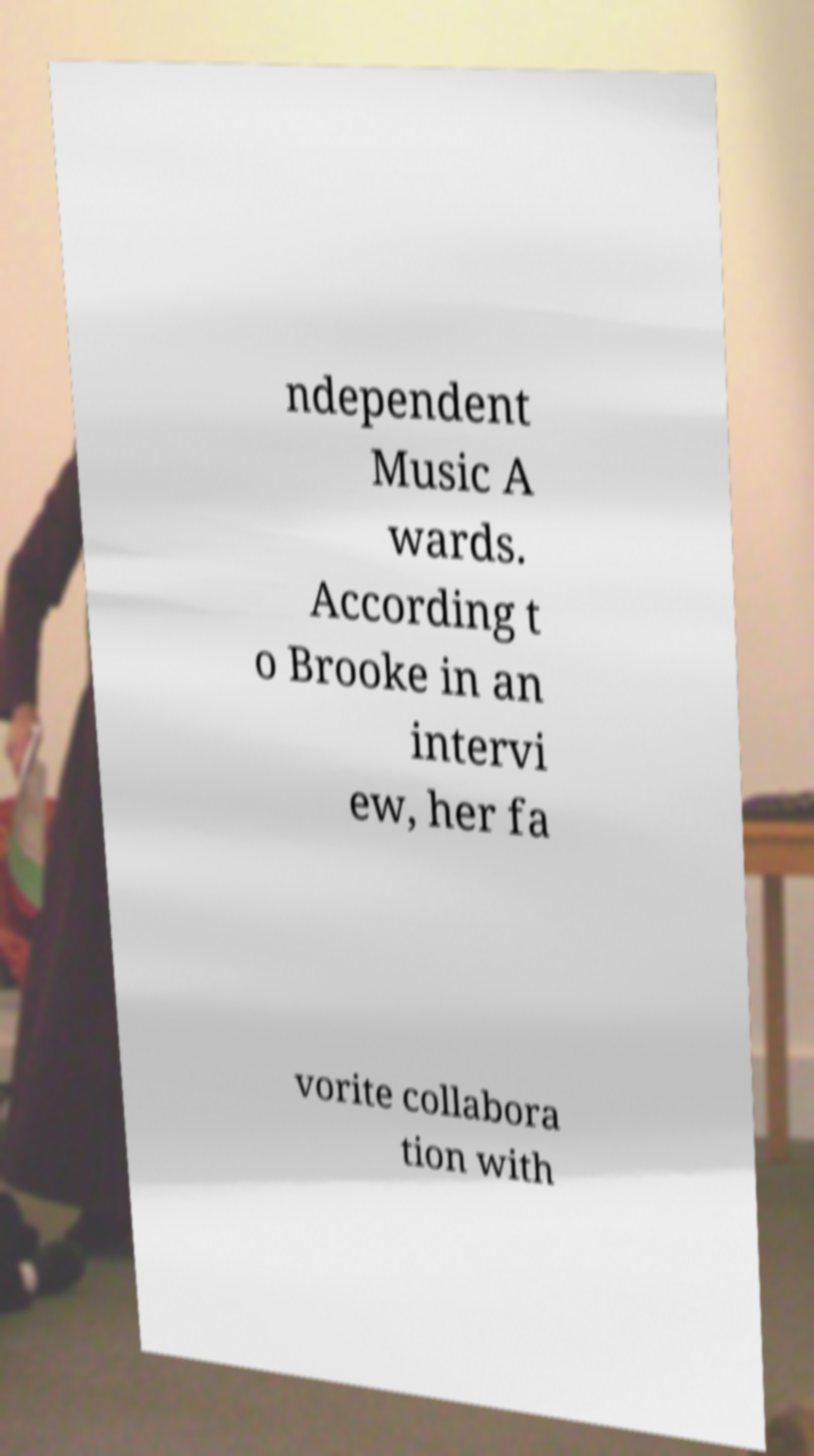Can you read and provide the text displayed in the image?This photo seems to have some interesting text. Can you extract and type it out for me? ndependent Music A wards. According t o Brooke in an intervi ew, her fa vorite collabora tion with 